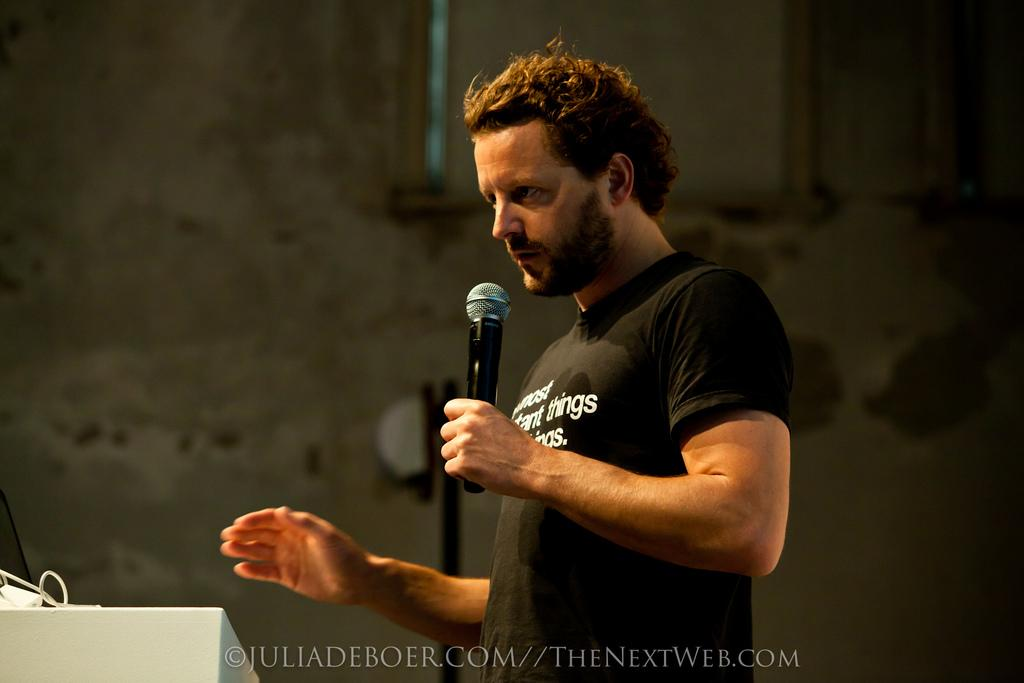What can be seen in the image? There is a person in the image. What is the person wearing? The person is wearing a black t-shirt. What is the person holding in the image? The person is holding a microphone. What type of rifle is the person holding in the image? There is no rifle present in the image; the person is holding a microphone. What arithmetic problem is the person solving in the image? There is no arithmetic problem present in the image; the person is holding a microphone. 